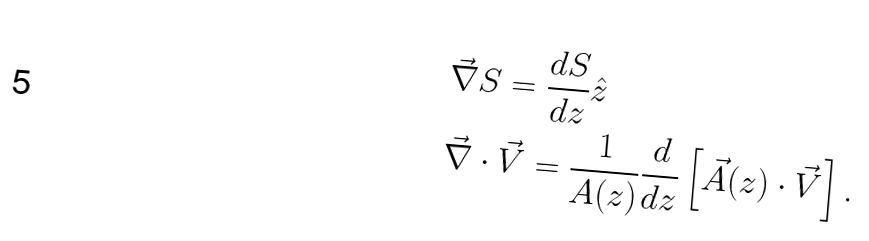<formula> <loc_0><loc_0><loc_500><loc_500>& \vec { \nabla } S = \frac { d S } { d z } \hat { z } \\ & \vec { \nabla } \cdot \vec { V } = \frac { 1 } { A ( z ) } \frac { d } { d z } \left [ \vec { A } ( z ) \cdot \vec { V } \right ] .</formula> 